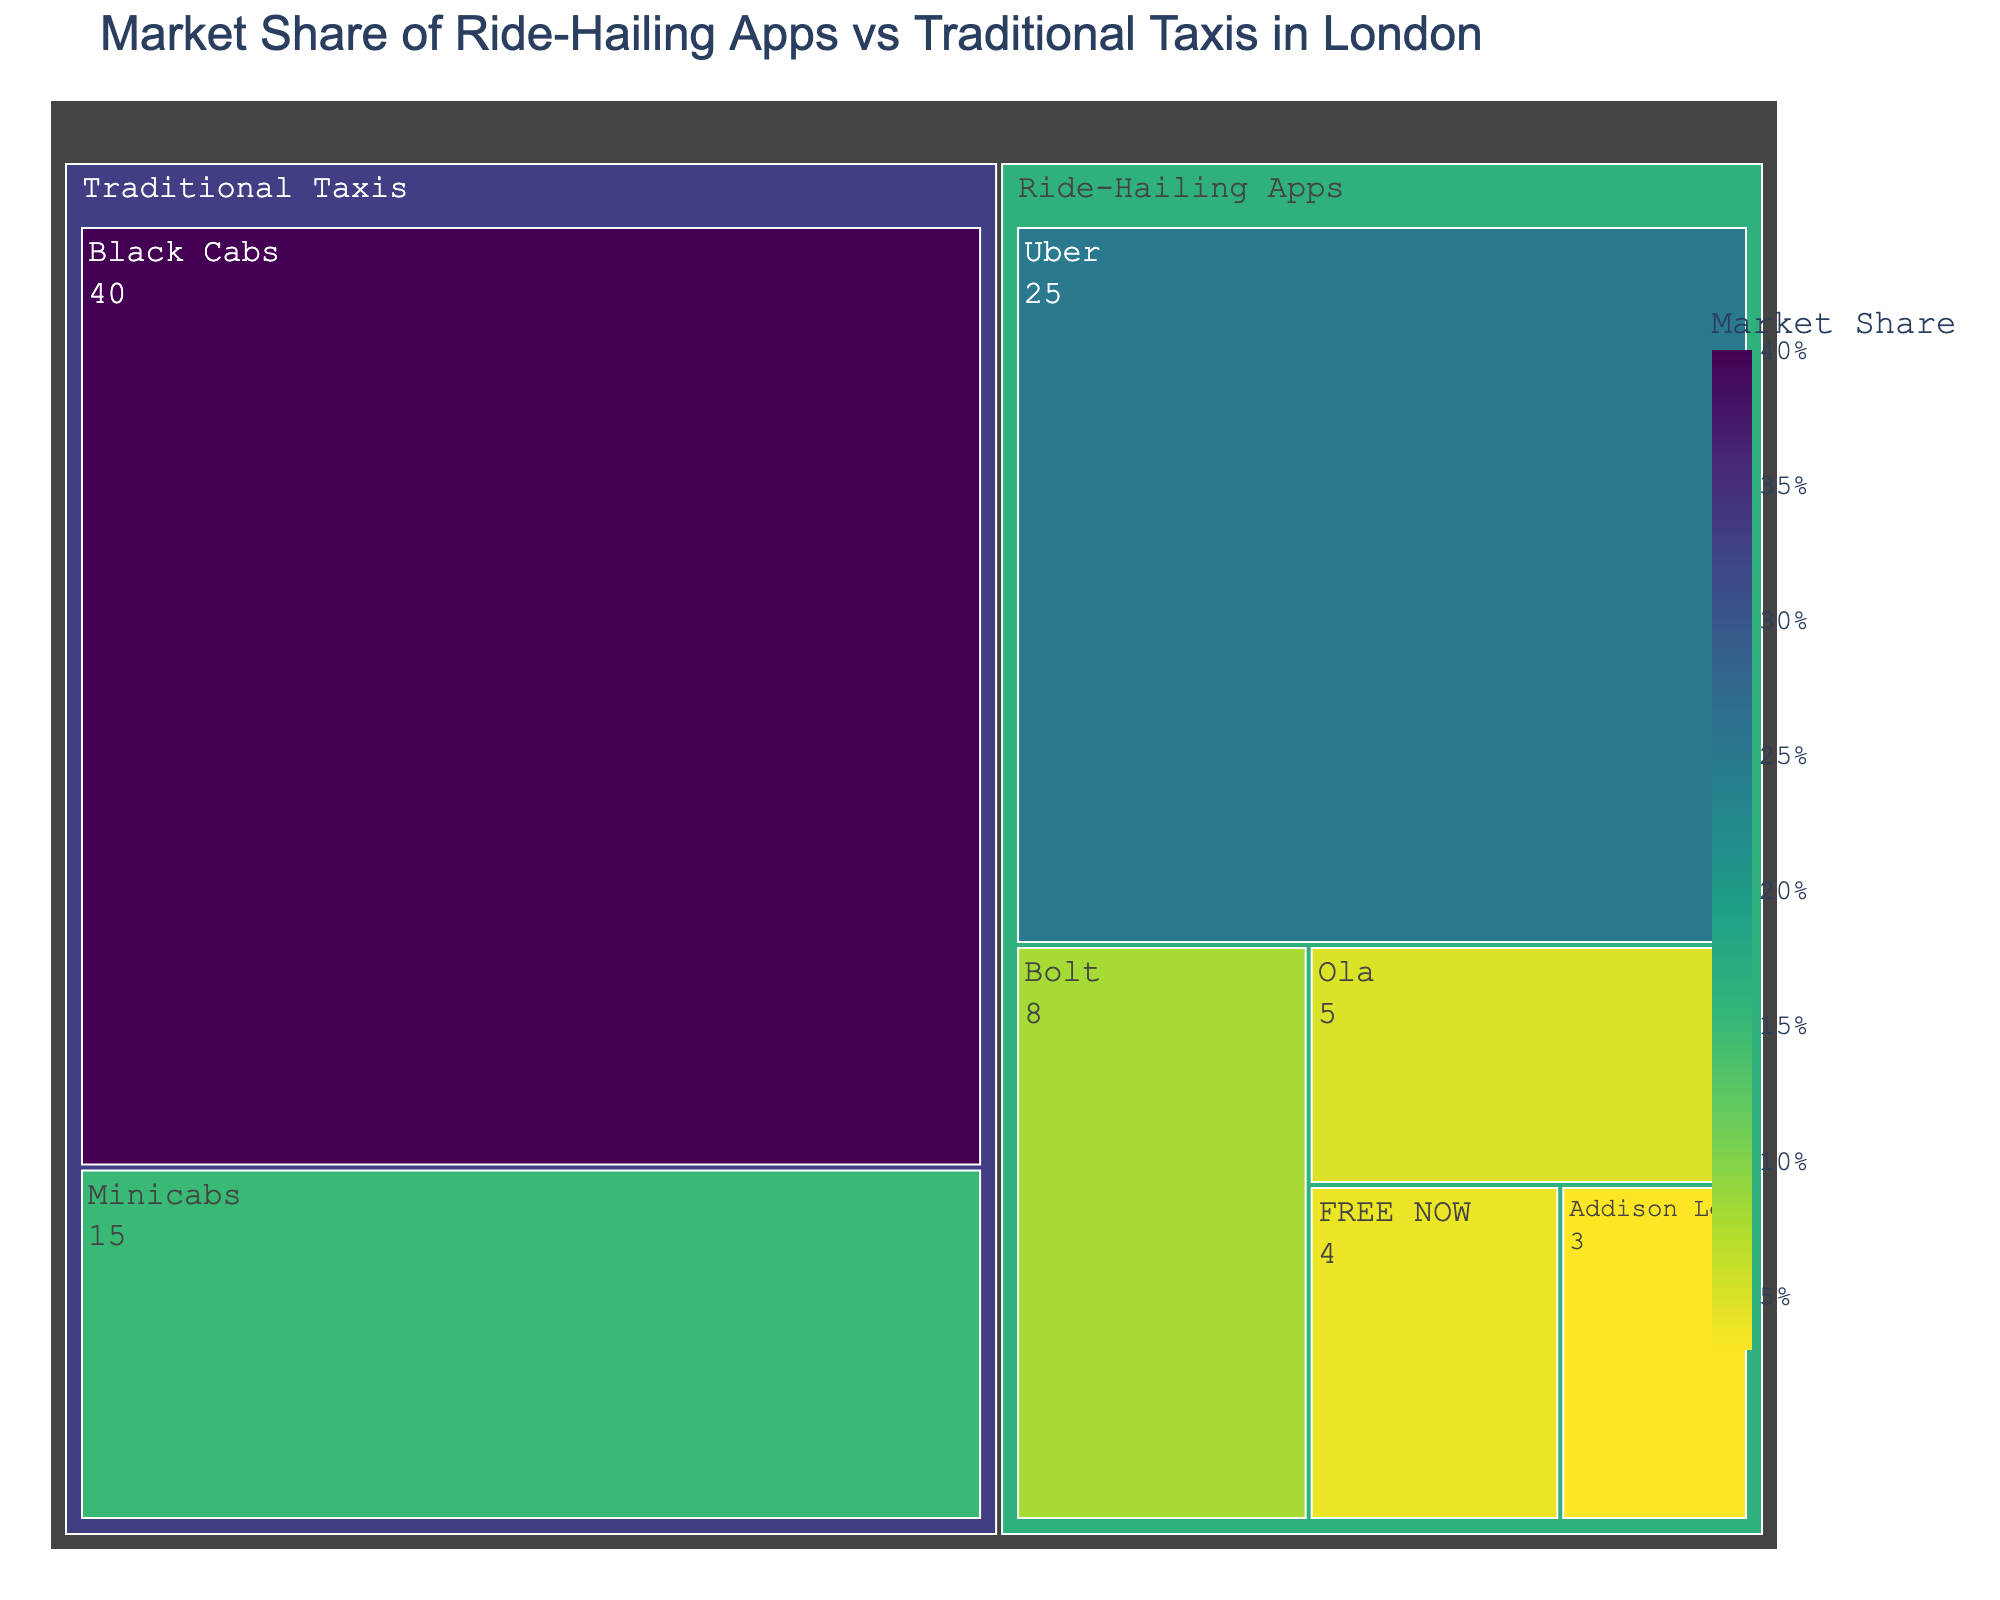What is the title of the treemap? The title is typically displayed at the top of the treemap, usually in a larger font size than the rest of the text. Here, it reads "Market Share of Ride-Hailing Apps vs Traditional Taxis in London."
Answer: Market Share of Ride-Hailing Apps vs Traditional Taxis in London Which traditional taxi category has the highest market share? The treemap shows two subcategories under Traditional Taxis: Black Cabs and Minicabs. By comparing their market share values, we see that Black Cabs has the highest with 40%.
Answer: Black Cabs What is the combined market share of all ride-hailing apps? The treemap shows multiple subcategories under Ride-Hailing Apps: Uber, Bolt, Ola, FREE NOW, and Addison Lee. Summing their market share values gives: 25 + 8 + 5 + 4 + 3 = 45%.
Answer: 45% What is the difference in market share between Black Cabs and Uber? Comparing the market share values of Black Cabs (40%) and Uber (25%), the difference is calculated as 40 - 25 = 15%.
Answer: 15% Which ride-hailing app has the smallest market share? Among the ride-hailing apps shown (Uber, Bolt, Ola, FREE NOW, Addison Lee), Addison Lee has the smallest market share with 3%.
Answer: Addison Lee Is the market share of Minicabs greater than that of Bolt? Comparing the values for Minicabs (15%) and Bolt (8%), we see that the market share of Minicabs is indeed greater than that of Bolt.
Answer: Yes What percentage of the market is not occupied by Black Cabs or Minicabs? First, find the combined market share of Black Cabs and Minicabs: 40 + 15 = 55%. Thus, the percentage of the market not occupied by them is 100 - 55 = 45%.
Answer: 45% How does the market share of Uber compare to the total market share of Minicabs and FREE NOW combined? Combining the market share of Minicabs (15%) and FREE NOW (4%) gives 15 + 4 = 19%. Uber’s market share is 25%, which is greater than the combined market share of Minicabs and FREE NOW.
Answer: Greater What's the average market share of the ride-hailing apps listed in the treemap? Add the market share of all ride-hailing apps (25, 8, 5, 4, and 3), which is 45. The total number of apps is 5. The average is 45 / 5 = 9%.
Answer: 9% How many categories and subcategories are presented in the treemap? The treemap has two main categories: Traditional Taxis and Ride-Hailing Apps. Traditional Taxis have 2 subcategories (Black Cabs, Minicabs) and Ride-Hailing Apps have 5 subcategories (Uber, Bolt, Ola, FREE NOW, Addison Lee). Hence, there are 2 categories and 7 subcategories.
Answer: 2 categories, 7 subcategories 